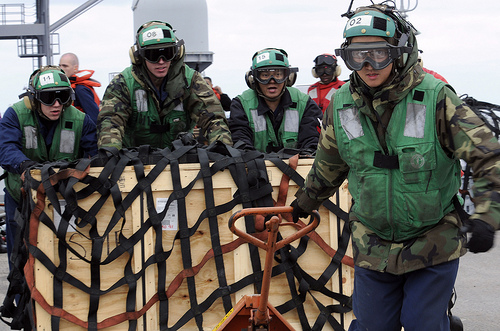<image>
Is there a man behind the crate? No. The man is not behind the crate. From this viewpoint, the man appears to be positioned elsewhere in the scene. Is the person next to the silo? No. The person is not positioned next to the silo. They are located in different areas of the scene. Where is the guy in relation to the guy? Is it in front of the guy? Yes. The guy is positioned in front of the guy, appearing closer to the camera viewpoint. 